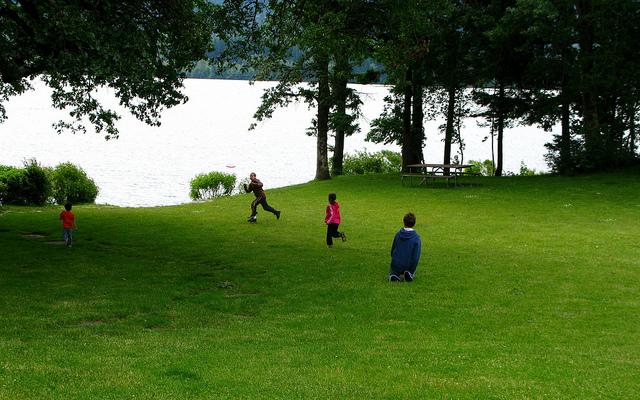Does the grass needs some maintenance?
Write a very short answer. No. What is the guy doing?
Keep it brief. Playing frisbee. How many people are in the picture?
Write a very short answer. 4. Is there a fence?
Short answer required. No. Why is he running?
Be succinct. To catch frisbee. Where behind the child has the parent probably told the child not to play?
Short answer required. Water. How many kids are there?
Write a very short answer. 4. What is behind the kids?
Answer briefly. Lake. 